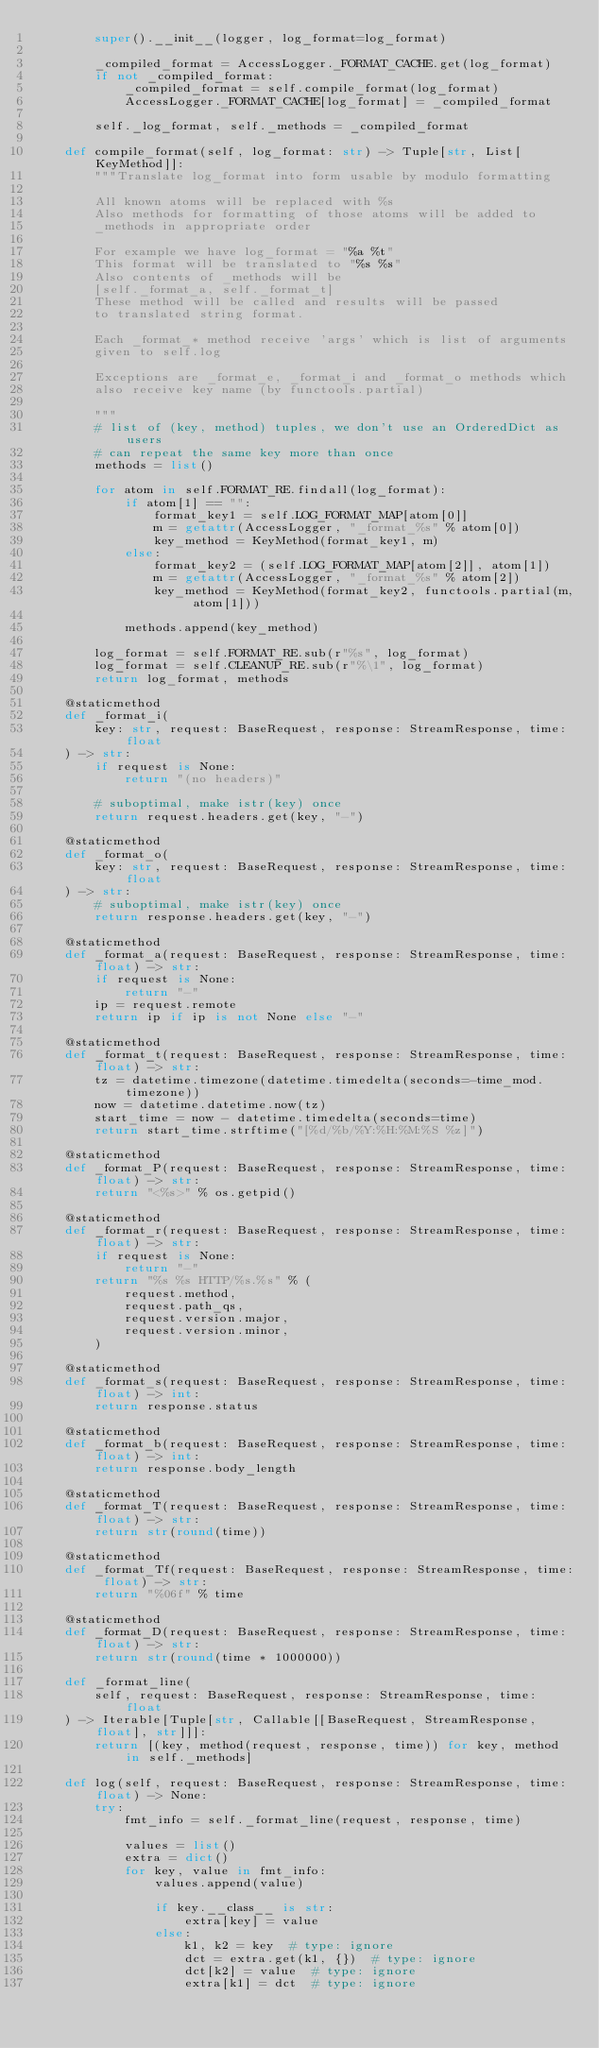Convert code to text. <code><loc_0><loc_0><loc_500><loc_500><_Python_>        super().__init__(logger, log_format=log_format)

        _compiled_format = AccessLogger._FORMAT_CACHE.get(log_format)
        if not _compiled_format:
            _compiled_format = self.compile_format(log_format)
            AccessLogger._FORMAT_CACHE[log_format] = _compiled_format

        self._log_format, self._methods = _compiled_format

    def compile_format(self, log_format: str) -> Tuple[str, List[KeyMethod]]:
        """Translate log_format into form usable by modulo formatting

        All known atoms will be replaced with %s
        Also methods for formatting of those atoms will be added to
        _methods in appropriate order

        For example we have log_format = "%a %t"
        This format will be translated to "%s %s"
        Also contents of _methods will be
        [self._format_a, self._format_t]
        These method will be called and results will be passed
        to translated string format.

        Each _format_* method receive 'args' which is list of arguments
        given to self.log

        Exceptions are _format_e, _format_i and _format_o methods which
        also receive key name (by functools.partial)

        """
        # list of (key, method) tuples, we don't use an OrderedDict as users
        # can repeat the same key more than once
        methods = list()

        for atom in self.FORMAT_RE.findall(log_format):
            if atom[1] == "":
                format_key1 = self.LOG_FORMAT_MAP[atom[0]]
                m = getattr(AccessLogger, "_format_%s" % atom[0])
                key_method = KeyMethod(format_key1, m)
            else:
                format_key2 = (self.LOG_FORMAT_MAP[atom[2]], atom[1])
                m = getattr(AccessLogger, "_format_%s" % atom[2])
                key_method = KeyMethod(format_key2, functools.partial(m, atom[1]))

            methods.append(key_method)

        log_format = self.FORMAT_RE.sub(r"%s", log_format)
        log_format = self.CLEANUP_RE.sub(r"%\1", log_format)
        return log_format, methods

    @staticmethod
    def _format_i(
        key: str, request: BaseRequest, response: StreamResponse, time: float
    ) -> str:
        if request is None:
            return "(no headers)"

        # suboptimal, make istr(key) once
        return request.headers.get(key, "-")

    @staticmethod
    def _format_o(
        key: str, request: BaseRequest, response: StreamResponse, time: float
    ) -> str:
        # suboptimal, make istr(key) once
        return response.headers.get(key, "-")

    @staticmethod
    def _format_a(request: BaseRequest, response: StreamResponse, time: float) -> str:
        if request is None:
            return "-"
        ip = request.remote
        return ip if ip is not None else "-"

    @staticmethod
    def _format_t(request: BaseRequest, response: StreamResponse, time: float) -> str:
        tz = datetime.timezone(datetime.timedelta(seconds=-time_mod.timezone))
        now = datetime.datetime.now(tz)
        start_time = now - datetime.timedelta(seconds=time)
        return start_time.strftime("[%d/%b/%Y:%H:%M:%S %z]")

    @staticmethod
    def _format_P(request: BaseRequest, response: StreamResponse, time: float) -> str:
        return "<%s>" % os.getpid()

    @staticmethod
    def _format_r(request: BaseRequest, response: StreamResponse, time: float) -> str:
        if request is None:
            return "-"
        return "%s %s HTTP/%s.%s" % (
            request.method,
            request.path_qs,
            request.version.major,
            request.version.minor,
        )

    @staticmethod
    def _format_s(request: BaseRequest, response: StreamResponse, time: float) -> int:
        return response.status

    @staticmethod
    def _format_b(request: BaseRequest, response: StreamResponse, time: float) -> int:
        return response.body_length

    @staticmethod
    def _format_T(request: BaseRequest, response: StreamResponse, time: float) -> str:
        return str(round(time))

    @staticmethod
    def _format_Tf(request: BaseRequest, response: StreamResponse, time: float) -> str:
        return "%06f" % time

    @staticmethod
    def _format_D(request: BaseRequest, response: StreamResponse, time: float) -> str:
        return str(round(time * 1000000))

    def _format_line(
        self, request: BaseRequest, response: StreamResponse, time: float
    ) -> Iterable[Tuple[str, Callable[[BaseRequest, StreamResponse, float], str]]]:
        return [(key, method(request, response, time)) for key, method in self._methods]

    def log(self, request: BaseRequest, response: StreamResponse, time: float) -> None:
        try:
            fmt_info = self._format_line(request, response, time)

            values = list()
            extra = dict()
            for key, value in fmt_info:
                values.append(value)

                if key.__class__ is str:
                    extra[key] = value
                else:
                    k1, k2 = key  # type: ignore
                    dct = extra.get(k1, {})  # type: ignore
                    dct[k2] = value  # type: ignore
                    extra[k1] = dct  # type: ignore
</code> 